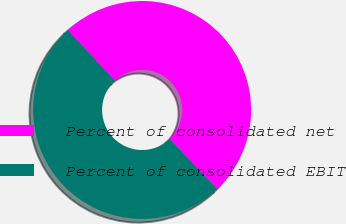Convert chart to OTSL. <chart><loc_0><loc_0><loc_500><loc_500><pie_chart><fcel>Percent of consolidated net<fcel>Percent of consolidated EBIT<nl><fcel>49.84%<fcel>50.16%<nl></chart> 